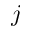<formula> <loc_0><loc_0><loc_500><loc_500>j</formula> 